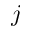<formula> <loc_0><loc_0><loc_500><loc_500>j</formula> 